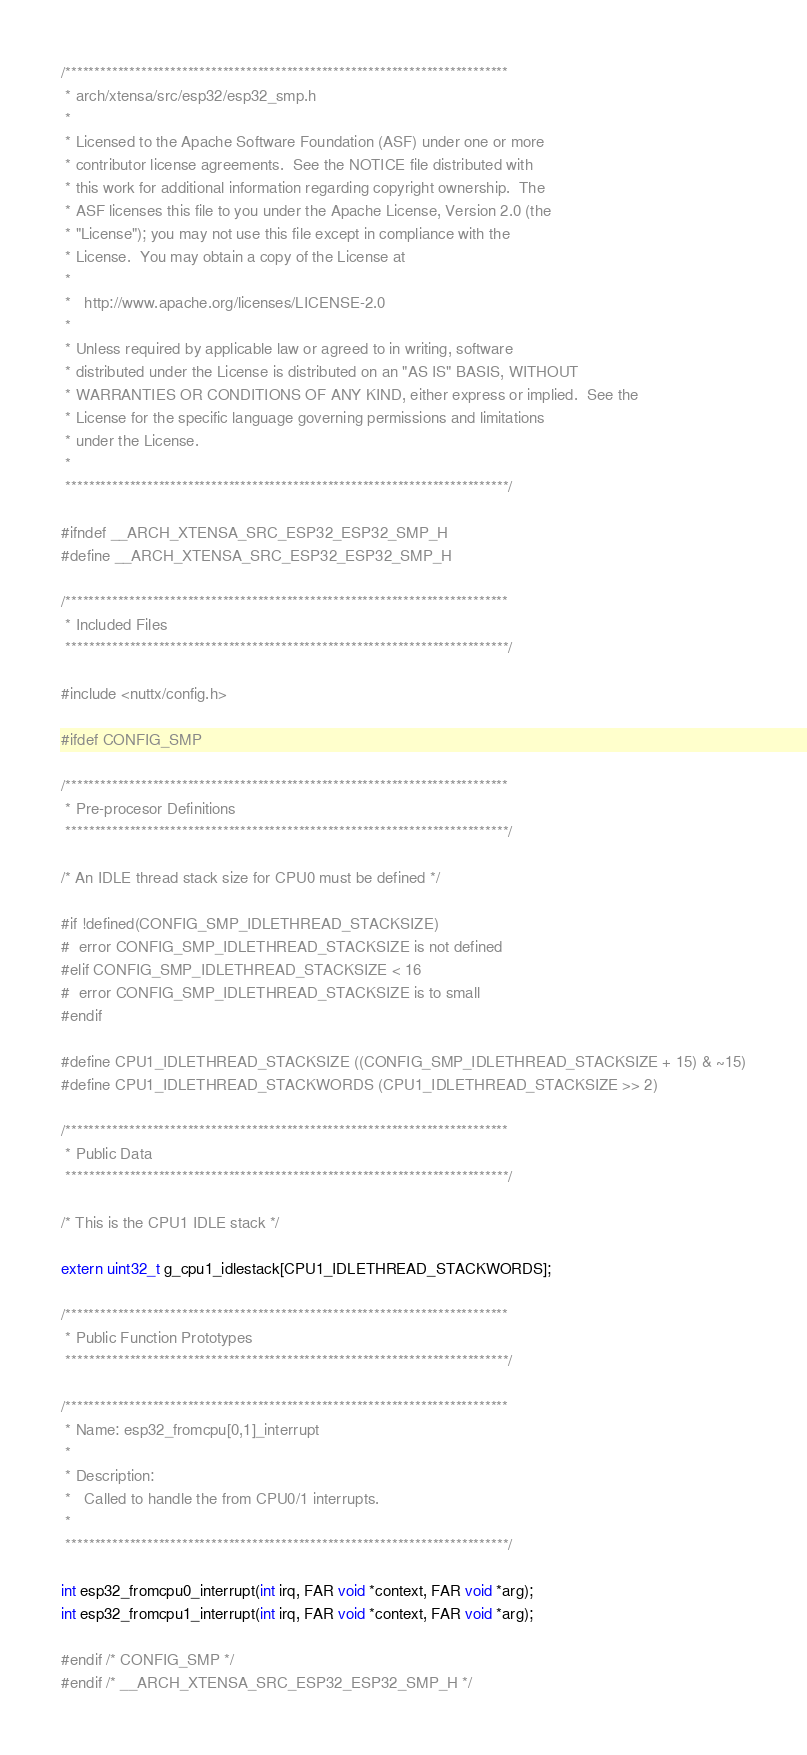Convert code to text. <code><loc_0><loc_0><loc_500><loc_500><_C_>/****************************************************************************
 * arch/xtensa/src/esp32/esp32_smp.h
 *
 * Licensed to the Apache Software Foundation (ASF) under one or more
 * contributor license agreements.  See the NOTICE file distributed with
 * this work for additional information regarding copyright ownership.  The
 * ASF licenses this file to you under the Apache License, Version 2.0 (the
 * "License"); you may not use this file except in compliance with the
 * License.  You may obtain a copy of the License at
 *
 *   http://www.apache.org/licenses/LICENSE-2.0
 *
 * Unless required by applicable law or agreed to in writing, software
 * distributed under the License is distributed on an "AS IS" BASIS, WITHOUT
 * WARRANTIES OR CONDITIONS OF ANY KIND, either express or implied.  See the
 * License for the specific language governing permissions and limitations
 * under the License.
 *
 ****************************************************************************/

#ifndef __ARCH_XTENSA_SRC_ESP32_ESP32_SMP_H
#define __ARCH_XTENSA_SRC_ESP32_ESP32_SMP_H

/****************************************************************************
 * Included Files
 ****************************************************************************/

#include <nuttx/config.h>

#ifdef CONFIG_SMP

/****************************************************************************
 * Pre-procesor Definitions
 ****************************************************************************/

/* An IDLE thread stack size for CPU0 must be defined */

#if !defined(CONFIG_SMP_IDLETHREAD_STACKSIZE)
#  error CONFIG_SMP_IDLETHREAD_STACKSIZE is not defined
#elif CONFIG_SMP_IDLETHREAD_STACKSIZE < 16
#  error CONFIG_SMP_IDLETHREAD_STACKSIZE is to small
#endif

#define CPU1_IDLETHREAD_STACKSIZE ((CONFIG_SMP_IDLETHREAD_STACKSIZE + 15) & ~15)
#define CPU1_IDLETHREAD_STACKWORDS (CPU1_IDLETHREAD_STACKSIZE >> 2)

/****************************************************************************
 * Public Data
 ****************************************************************************/

/* This is the CPU1 IDLE stack */

extern uint32_t g_cpu1_idlestack[CPU1_IDLETHREAD_STACKWORDS];

/****************************************************************************
 * Public Function Prototypes
 ****************************************************************************/

/****************************************************************************
 * Name: esp32_fromcpu[0,1]_interrupt
 *
 * Description:
 *   Called to handle the from CPU0/1 interrupts.
 *
 ****************************************************************************/

int esp32_fromcpu0_interrupt(int irq, FAR void *context, FAR void *arg);
int esp32_fromcpu1_interrupt(int irq, FAR void *context, FAR void *arg);

#endif /* CONFIG_SMP */
#endif /* __ARCH_XTENSA_SRC_ESP32_ESP32_SMP_H */
</code> 